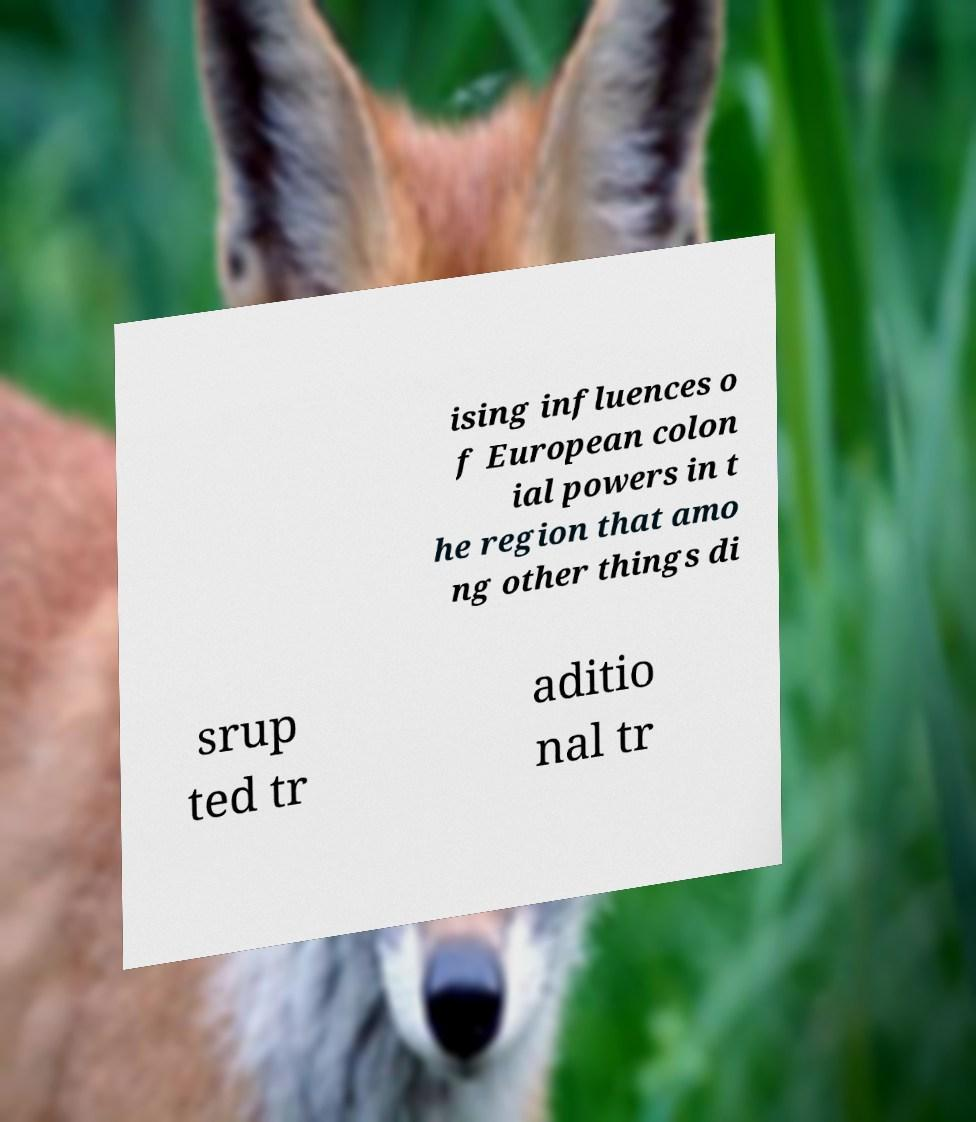There's text embedded in this image that I need extracted. Can you transcribe it verbatim? ising influences o f European colon ial powers in t he region that amo ng other things di srup ted tr aditio nal tr 